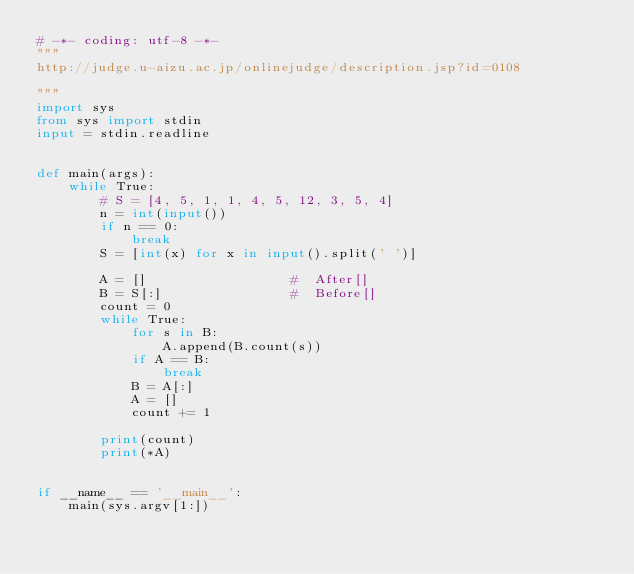Convert code to text. <code><loc_0><loc_0><loc_500><loc_500><_Python_># -*- coding: utf-8 -*-
"""
http://judge.u-aizu.ac.jp/onlinejudge/description.jsp?id=0108

"""
import sys
from sys import stdin
input = stdin.readline


def main(args):
    while True:
        # S = [4, 5, 1, 1, 4, 5, 12, 3, 5, 4]
        n = int(input())
        if n == 0:
            break
        S = [int(x) for x in input().split(' ')]

        A = []                  #  After[]
        B = S[:]                #  Before[]
        count = 0
        while True:
            for s in B:
                A.append(B.count(s))
            if A == B:
                break
            B = A[:]
            A = []
            count += 1

        print(count)
        print(*A)


if __name__ == '__main__':
    main(sys.argv[1:])
    </code> 